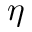Convert formula to latex. <formula><loc_0><loc_0><loc_500><loc_500>\eta</formula> 